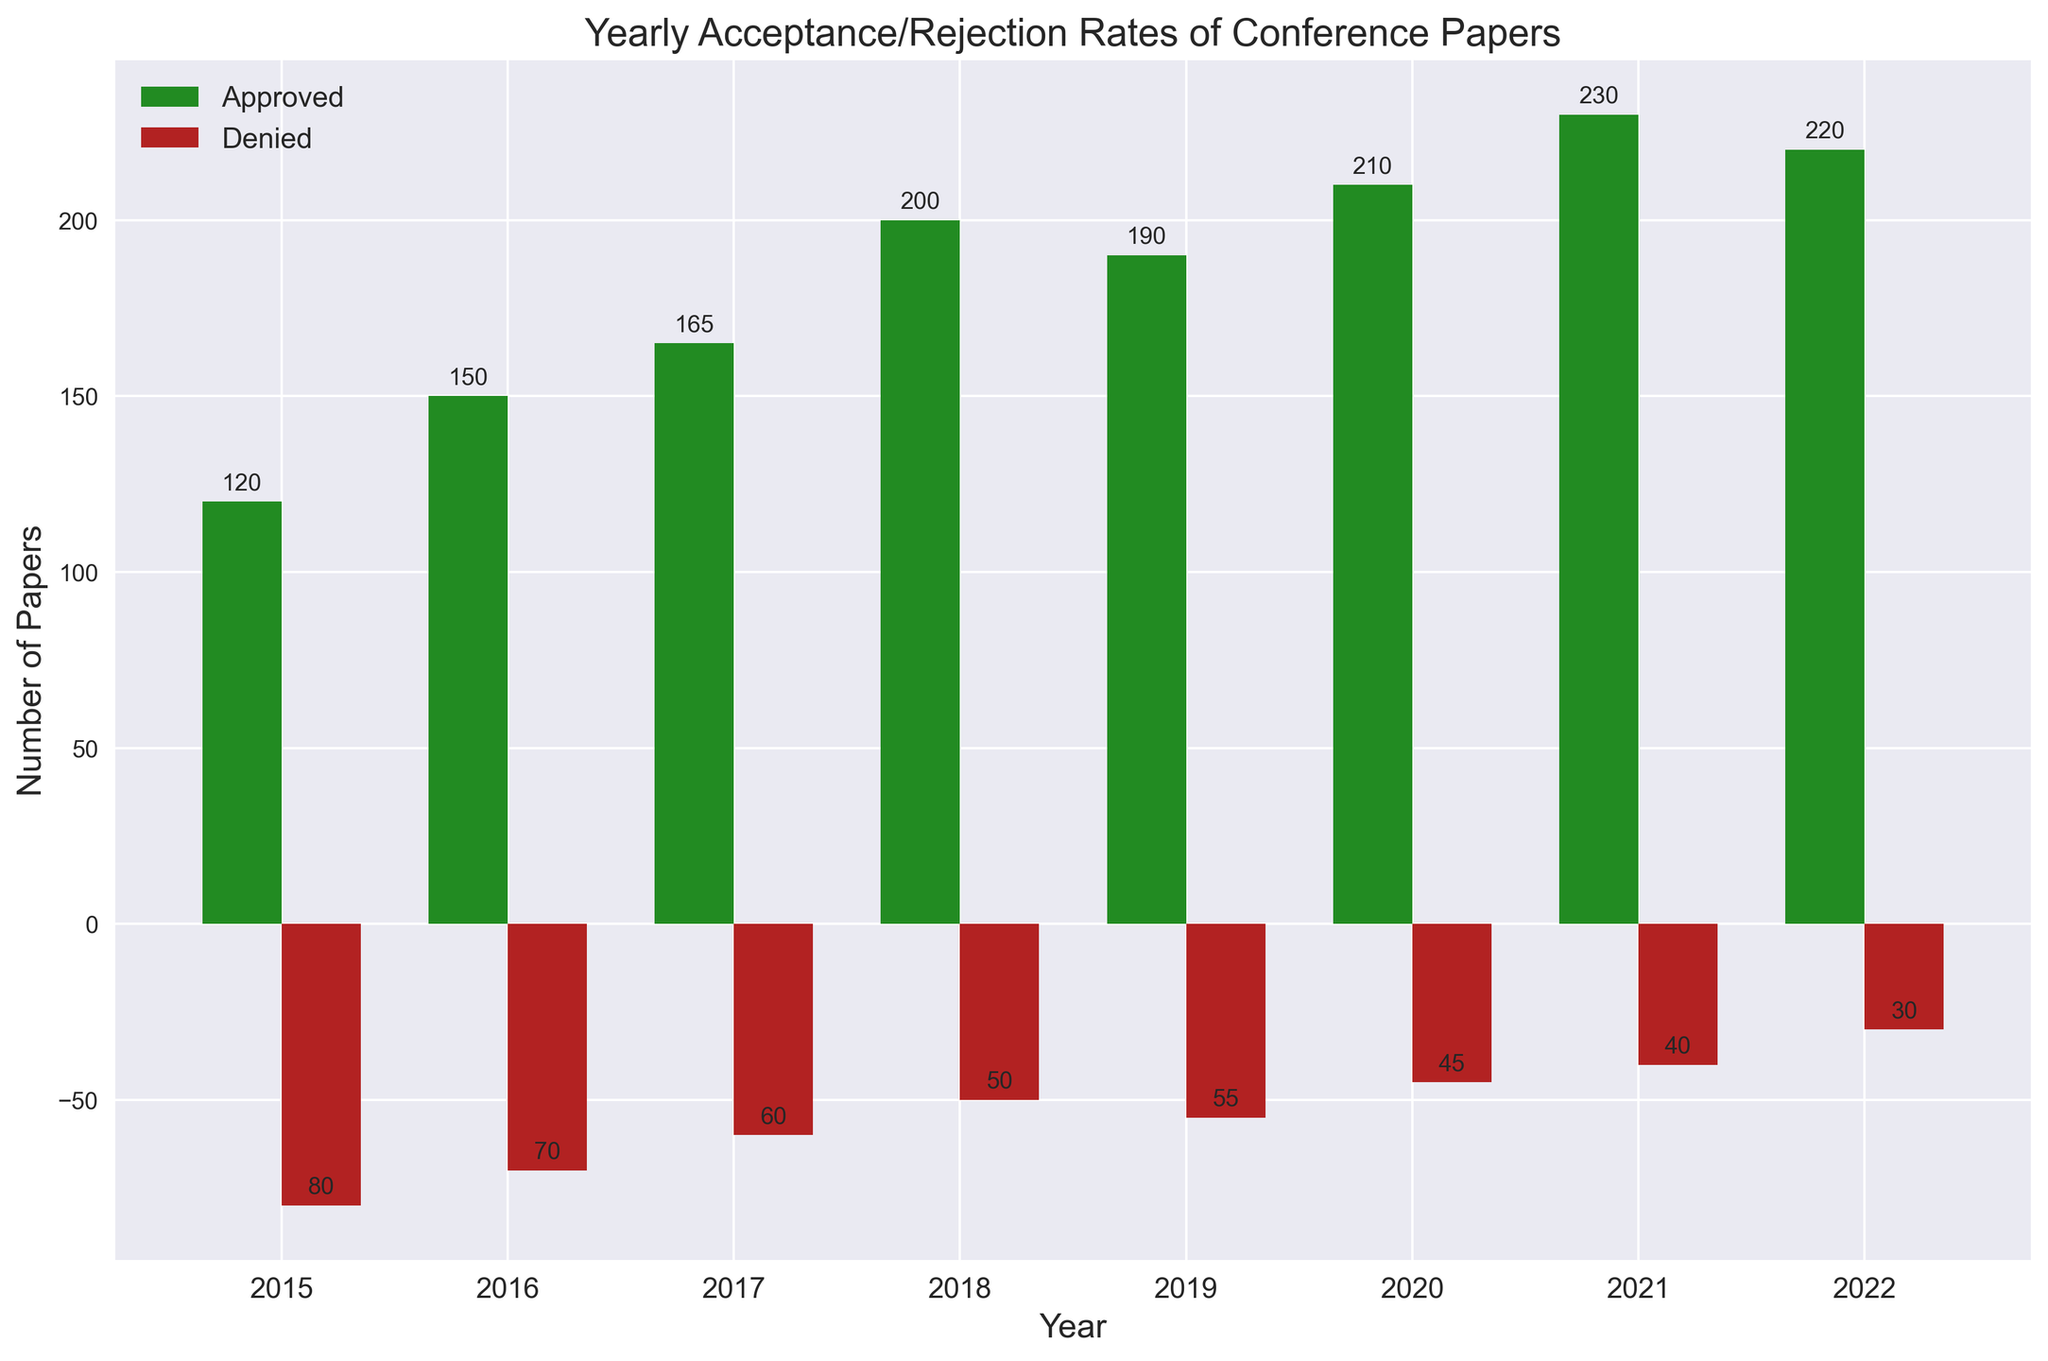What is the total number of approved papers in 2022? To find the total number of approved papers in 2022, look at the green bar labeled 2022.
Answer: 220 Which year has the highest number of denied papers? Compare the heights of red bars across all years to identify the year with the tallest red bar.
Answer: 2015 By how much did the number of approved papers increase from 2015 to 2021? Subtract the number of approved papers in 2015 from that in 2021. 230 (in 2021) - 120 (in 2015) = 110.
Answer: 110 What is the difference between approved and denied papers in 2020? Subtract the number of denied papers from approved papers for 2020. 210 (approved) - 45 (denied) = 165.
Answer: 165 What is the trend of denied paper submissions from 2015 to 2022? Observe the red bars over the years, noticing whether they increase, decrease, or stay constant. They decrease over time.
Answer: Decreasing In which year is the difference between approved and denied papers the smallest? Compute the differences for each year and identify the smallest one. For each year, the differences are: 2015: 120 - 80 = 40, 2016: 150 - 70 = 80, 2017: 165 - 60 = 105, 2018: 200 - 50 = 150, 2019: 190 - 55 = 135, 2020: 210 - 45 = 165, 2021: 230 - 40 = 190, 2022: 220 - 30 = 190. The smallest is 40 in 2015.
Answer: 2015 Are there any years where denied submissions are less than half the approved submissions? For each year, check if denied submissions < 0.5 * approved submissions. 2018: 50 < 0.5 * 200, 2019: 55 < 0.5 * 190, 2020: 45 < 0.5 * 210, 2021: 40 < 0.5 * 230, 2022: 30 < 0.5 * 220.
Answer: Yes What is the mean number of denied papers from 2015 to 2022? Sum all denied papers from 2015 to 2022 and then divide by the number of years (8). (80 + 70 + 60 + 50 + 55 + 45 + 40 + 30) / 8 = 54.
Answer: 54 